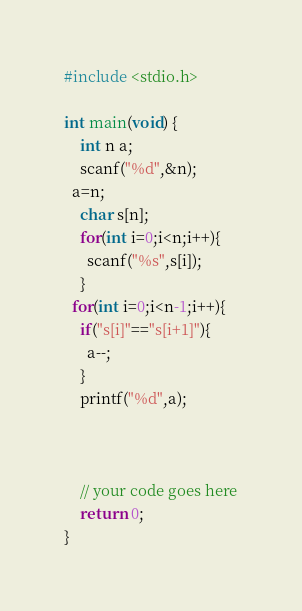Convert code to text. <code><loc_0><loc_0><loc_500><loc_500><_C_>#include <stdio.h>

int main(void) {
	int n a;
	scanf("%d",&n);
  a=n;
	char s[n];
	for(int i=0;i<n;i++){
      scanf("%s",s[i]);
    }
  for(int i=0;i<n-1;i++){
    if("s[i]"=="s[i+1]"){
      a--;
    }
    printf("%d",a);
    
  
  
	// your code goes here
	return 0;
}
</code> 